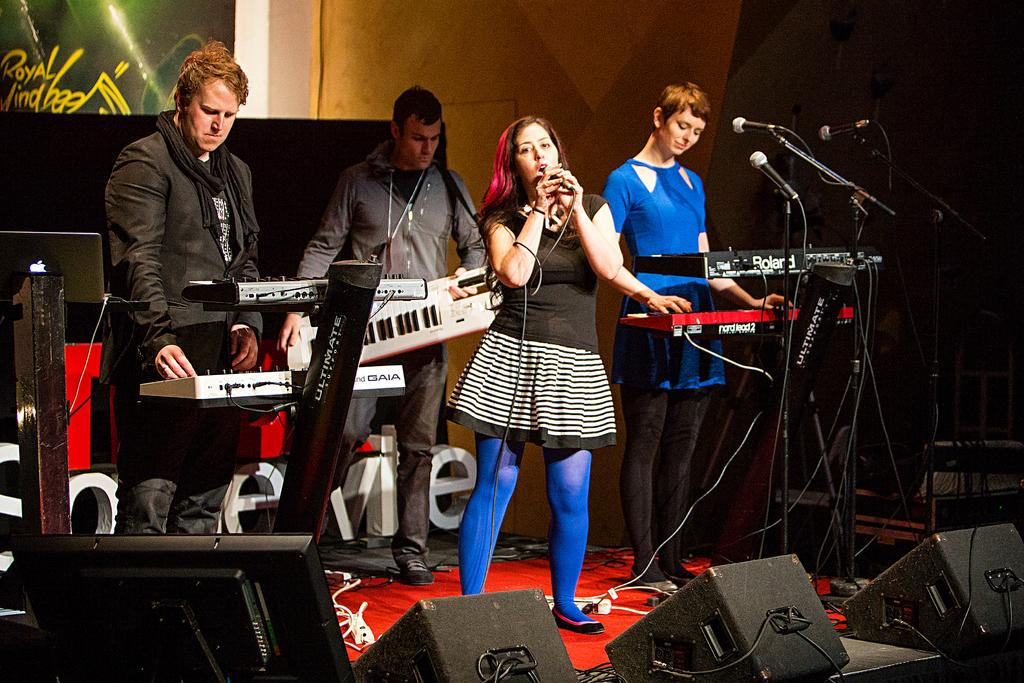Who is the main subject in the image? There is a woman in the image. What is the woman doing in the image? The woman is singing. What is the woman holding in the image? The woman is holding a microphone. What else can be seen in the image besides the woman? There are persons playing musical instruments in the image. What is used to hold the microphone in the image? There is a microphone with a holder in the image. What type of comb can be seen in the woman's hair in the image? There is no comb visible in the woman's hair in the image. Is there a slope in the background of the image? There is no slope present in the image; it features a woman singing and persons playing musical instruments. 